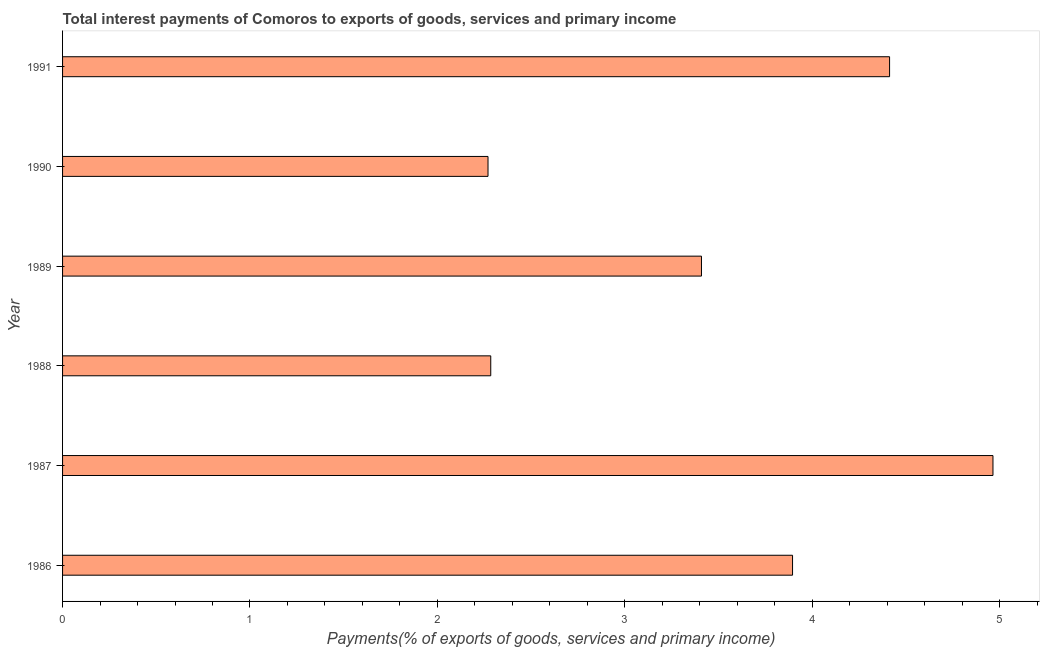Does the graph contain grids?
Offer a terse response. No. What is the title of the graph?
Provide a short and direct response. Total interest payments of Comoros to exports of goods, services and primary income. What is the label or title of the X-axis?
Your answer should be very brief. Payments(% of exports of goods, services and primary income). What is the total interest payments on external debt in 1988?
Offer a terse response. 2.28. Across all years, what is the maximum total interest payments on external debt?
Make the answer very short. 4.96. Across all years, what is the minimum total interest payments on external debt?
Offer a very short reply. 2.27. In which year was the total interest payments on external debt maximum?
Ensure brevity in your answer.  1987. In which year was the total interest payments on external debt minimum?
Give a very brief answer. 1990. What is the sum of the total interest payments on external debt?
Give a very brief answer. 21.24. What is the difference between the total interest payments on external debt in 1987 and 1990?
Your answer should be very brief. 2.69. What is the average total interest payments on external debt per year?
Your answer should be very brief. 3.54. What is the median total interest payments on external debt?
Your response must be concise. 3.65. In how many years, is the total interest payments on external debt greater than 0.4 %?
Your answer should be compact. 6. What is the ratio of the total interest payments on external debt in 1990 to that in 1991?
Ensure brevity in your answer.  0.51. What is the difference between the highest and the second highest total interest payments on external debt?
Offer a very short reply. 0.55. What is the difference between the highest and the lowest total interest payments on external debt?
Your answer should be very brief. 2.69. In how many years, is the total interest payments on external debt greater than the average total interest payments on external debt taken over all years?
Give a very brief answer. 3. Are all the bars in the graph horizontal?
Make the answer very short. Yes. How many years are there in the graph?
Offer a terse response. 6. What is the difference between two consecutive major ticks on the X-axis?
Your answer should be very brief. 1. Are the values on the major ticks of X-axis written in scientific E-notation?
Your answer should be compact. No. What is the Payments(% of exports of goods, services and primary income) in 1986?
Keep it short and to the point. 3.9. What is the Payments(% of exports of goods, services and primary income) of 1987?
Make the answer very short. 4.96. What is the Payments(% of exports of goods, services and primary income) of 1988?
Give a very brief answer. 2.28. What is the Payments(% of exports of goods, services and primary income) in 1989?
Your response must be concise. 3.41. What is the Payments(% of exports of goods, services and primary income) of 1990?
Your response must be concise. 2.27. What is the Payments(% of exports of goods, services and primary income) of 1991?
Your response must be concise. 4.41. What is the difference between the Payments(% of exports of goods, services and primary income) in 1986 and 1987?
Your answer should be very brief. -1.07. What is the difference between the Payments(% of exports of goods, services and primary income) in 1986 and 1988?
Provide a succinct answer. 1.61. What is the difference between the Payments(% of exports of goods, services and primary income) in 1986 and 1989?
Your response must be concise. 0.49. What is the difference between the Payments(% of exports of goods, services and primary income) in 1986 and 1990?
Provide a succinct answer. 1.62. What is the difference between the Payments(% of exports of goods, services and primary income) in 1986 and 1991?
Offer a terse response. -0.52. What is the difference between the Payments(% of exports of goods, services and primary income) in 1987 and 1988?
Offer a very short reply. 2.68. What is the difference between the Payments(% of exports of goods, services and primary income) in 1987 and 1989?
Offer a very short reply. 1.56. What is the difference between the Payments(% of exports of goods, services and primary income) in 1987 and 1990?
Offer a terse response. 2.69. What is the difference between the Payments(% of exports of goods, services and primary income) in 1987 and 1991?
Offer a terse response. 0.55. What is the difference between the Payments(% of exports of goods, services and primary income) in 1988 and 1989?
Provide a succinct answer. -1.12. What is the difference between the Payments(% of exports of goods, services and primary income) in 1988 and 1990?
Ensure brevity in your answer.  0.01. What is the difference between the Payments(% of exports of goods, services and primary income) in 1988 and 1991?
Ensure brevity in your answer.  -2.13. What is the difference between the Payments(% of exports of goods, services and primary income) in 1989 and 1990?
Make the answer very short. 1.14. What is the difference between the Payments(% of exports of goods, services and primary income) in 1989 and 1991?
Your answer should be very brief. -1. What is the difference between the Payments(% of exports of goods, services and primary income) in 1990 and 1991?
Ensure brevity in your answer.  -2.14. What is the ratio of the Payments(% of exports of goods, services and primary income) in 1986 to that in 1987?
Give a very brief answer. 0.79. What is the ratio of the Payments(% of exports of goods, services and primary income) in 1986 to that in 1988?
Give a very brief answer. 1.71. What is the ratio of the Payments(% of exports of goods, services and primary income) in 1986 to that in 1989?
Offer a very short reply. 1.14. What is the ratio of the Payments(% of exports of goods, services and primary income) in 1986 to that in 1990?
Ensure brevity in your answer.  1.72. What is the ratio of the Payments(% of exports of goods, services and primary income) in 1986 to that in 1991?
Provide a succinct answer. 0.88. What is the ratio of the Payments(% of exports of goods, services and primary income) in 1987 to that in 1988?
Offer a terse response. 2.17. What is the ratio of the Payments(% of exports of goods, services and primary income) in 1987 to that in 1989?
Your answer should be very brief. 1.46. What is the ratio of the Payments(% of exports of goods, services and primary income) in 1987 to that in 1990?
Your response must be concise. 2.19. What is the ratio of the Payments(% of exports of goods, services and primary income) in 1988 to that in 1989?
Make the answer very short. 0.67. What is the ratio of the Payments(% of exports of goods, services and primary income) in 1988 to that in 1991?
Provide a short and direct response. 0.52. What is the ratio of the Payments(% of exports of goods, services and primary income) in 1989 to that in 1990?
Give a very brief answer. 1.5. What is the ratio of the Payments(% of exports of goods, services and primary income) in 1989 to that in 1991?
Make the answer very short. 0.77. What is the ratio of the Payments(% of exports of goods, services and primary income) in 1990 to that in 1991?
Offer a terse response. 0.51. 